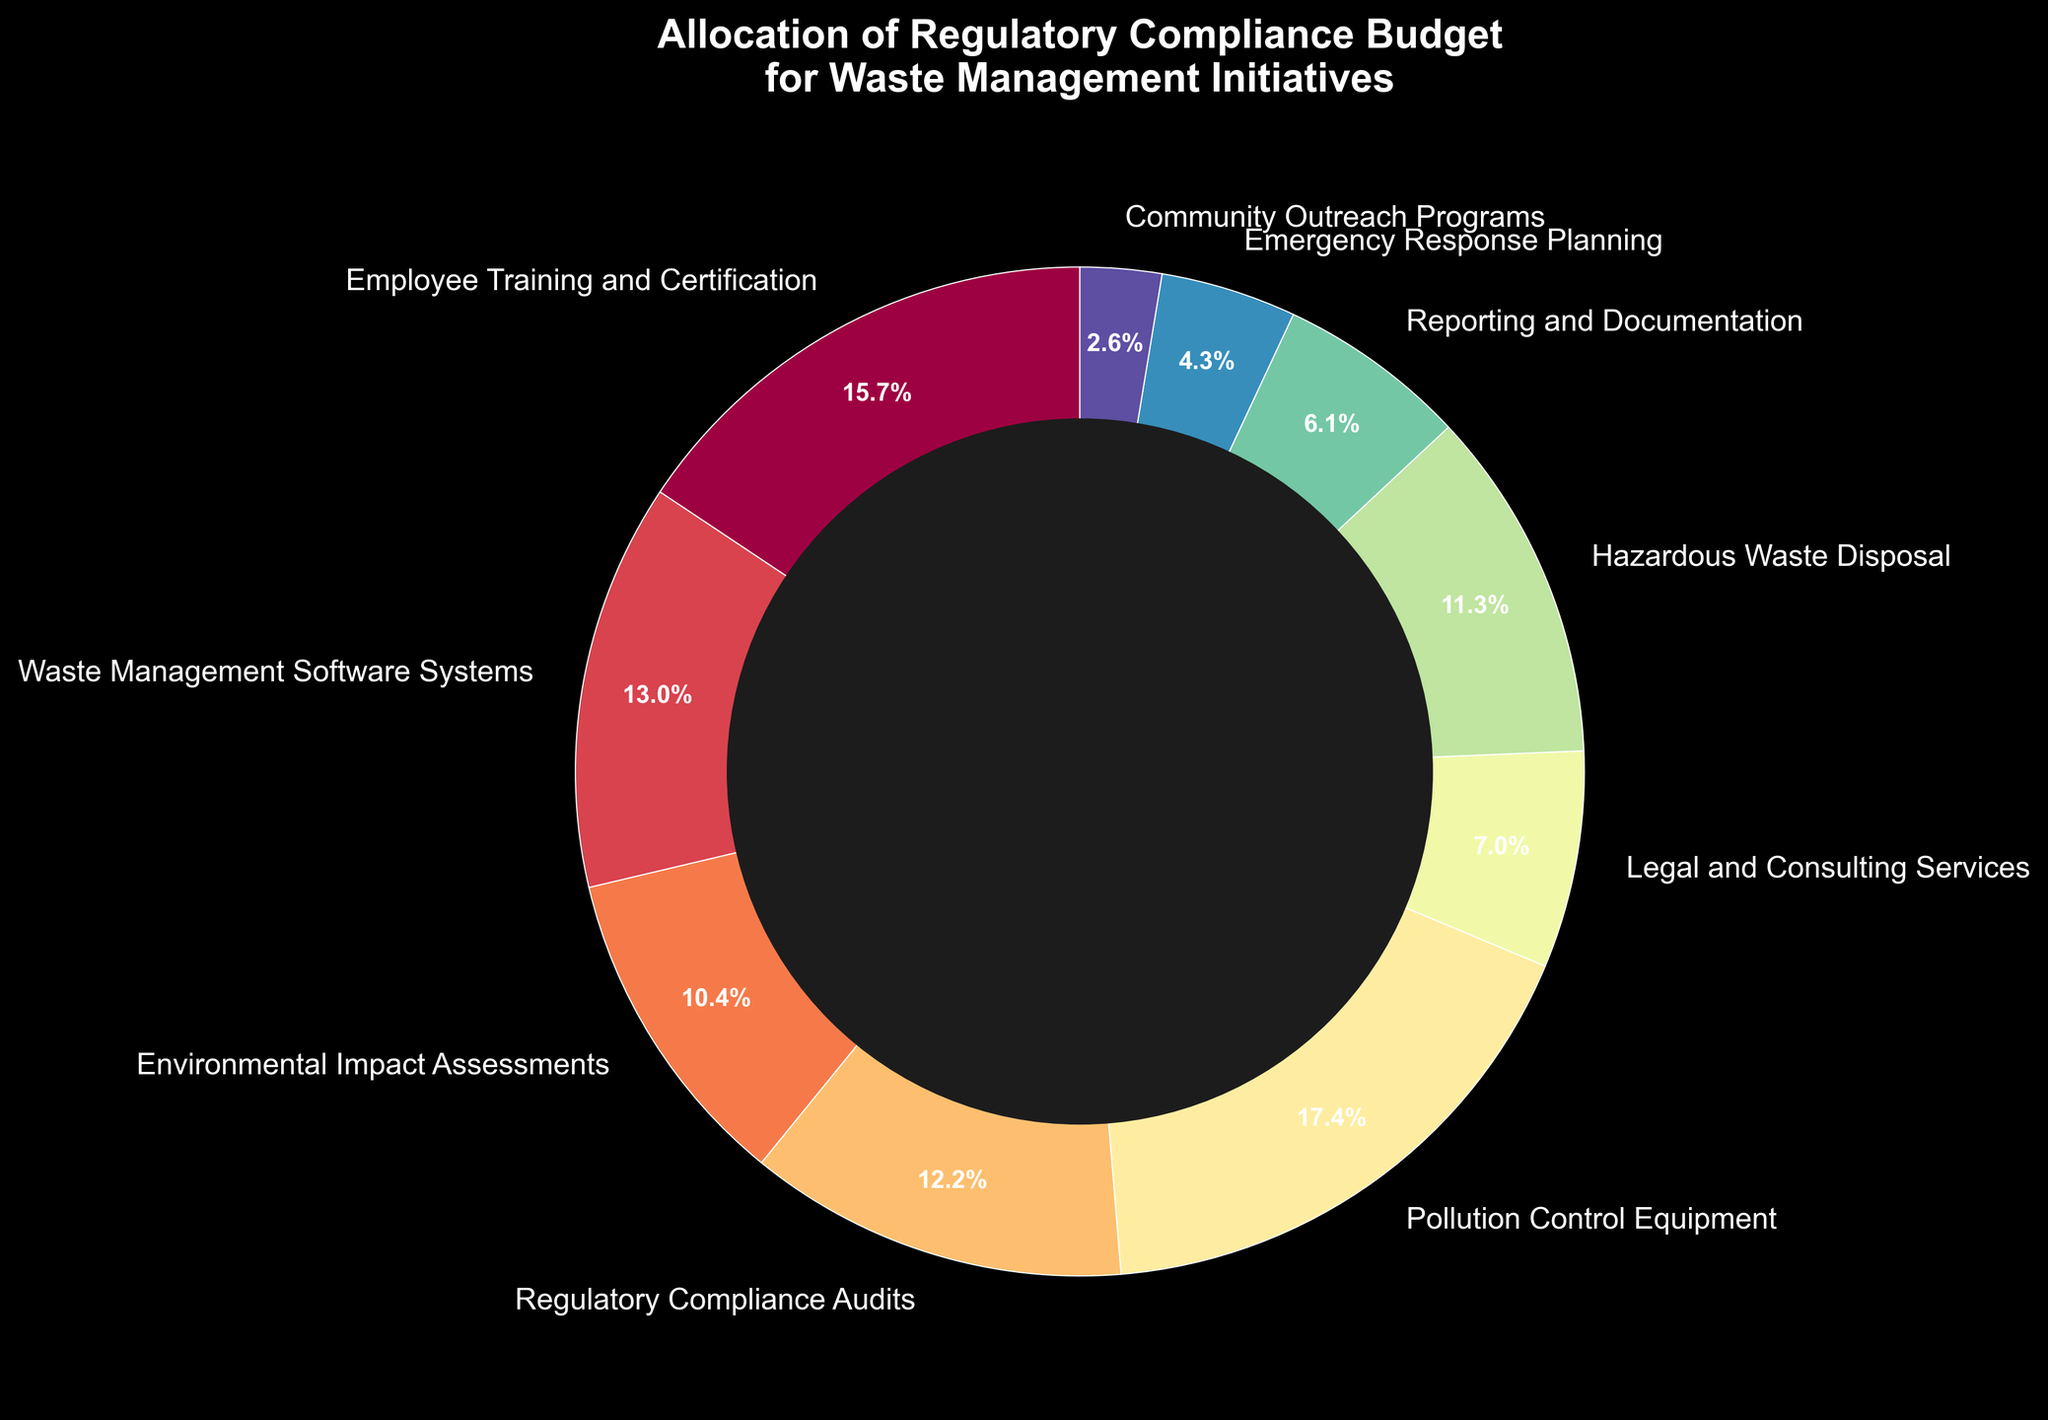Which budget category has the highest allocation? Identify the budget category with the largest percentage allocation in the pie chart by comparing all the slices. The largest slice represents Pollution Control Equipment, which has 20%.
Answer: Pollution Control Equipment What is the combined allocation percentage for Employee Training and Certification and Hazardous Waste Disposal? Find the allocation percentage for Employee Training and Certification (18%) and Hazardous Waste Disposal (13%) and add them together: 18% + 13% = 31%.
Answer: 31% How much more is allocated to Pollution Control Equipment than to Community Outreach Programs? Find the allocation percentages for Pollution Control Equipment (20%) and Community Outreach Programs (3%) and calculate the difference: 20% - 3% = 17%.
Answer: 17% Which categories have an allocation percentage less than 10%? Identify the slices with percentages less than 10%, which are Legal and Consulting Services (8%), Reporting and Documentation (7%), Emergency Response Planning (5%), and Community Outreach Programs (3%).
Answer: Legal and Consulting Services, Reporting and Documentation, Emergency Response Planning, Community Outreach Programs Is the allocation to Waste Management Software Systems greater than the allocation to Environmental Impact Assessments? Compare the allocation percentages: Waste Management Software Systems has 15%, and Environmental Impact Assessments has 12%. Since 15% > 12%, the allocation to Waste Management Software Systems is greater.
Answer: Yes What is the average allocation percentage for all categories that have more than 10% allocation? Identify categories with more than 10% allocation: Employee Training and Certification (18%), Waste Management Software Systems (15%), Environmental Impact Assessments (12%), Regulatory Compliance Audits (14%), Pollution Control Equipment (20%), and Hazardous Waste Disposal (13%). Compute the average: (18% + 15% + 12% + 14% + 20% + 13%)/6 ≈ 15.33%.
Answer: 15.33% What proportion of the total budget is allocated to categories involved in direct waste management (e.g., Hazardous Waste Disposal, Pollution Control Equipment, Waste Management Software Systems)? Find the allocation percentages for Hazardous Waste Disposal (13%), Pollution Control Equipment (20%), and Waste Management Software Systems (15%) and add them together: 13% + 20% + 15% = 48%.
Answer: 48% How does the allocation for Regulatory Compliance Audits compare to that for Emergency Response Planning? Compare the allocation percentages: Regulatory Compliance Audits has 14%, and Emergency Response Planning has 5%. Since 14% > 5%, the allocation for Regulatory Compliance Audits is higher.
Answer: Regulatory Compliance Audits allocation is higher What percentage of the budget is allocated to Legal and Consulting Services, Reporting and Documentation, and Community Outreach Programs combined? Add the allocation percentages for Legal and Consulting Services (8%), Reporting and Documentation (7%), and Community Outreach Programs (3%): 8% + 7% + 3% = 18%.
Answer: 18% If we were to redistribute 5% from Pollution Control Equipment to Employee Training and Certification, what would the new allocation percentages for these two categories be? Subtract 5% from Pollution Control Equipment (20% - 5% = 15%) and add 5% to Employee Training and Certification (18% + 5% = 23%). The new percentages would be 15% for Pollution Control Equipment and 23% for Employee Training and Certification.
Answer: 15% for Pollution Control Equipment, 23% for Employee Training and Certification 